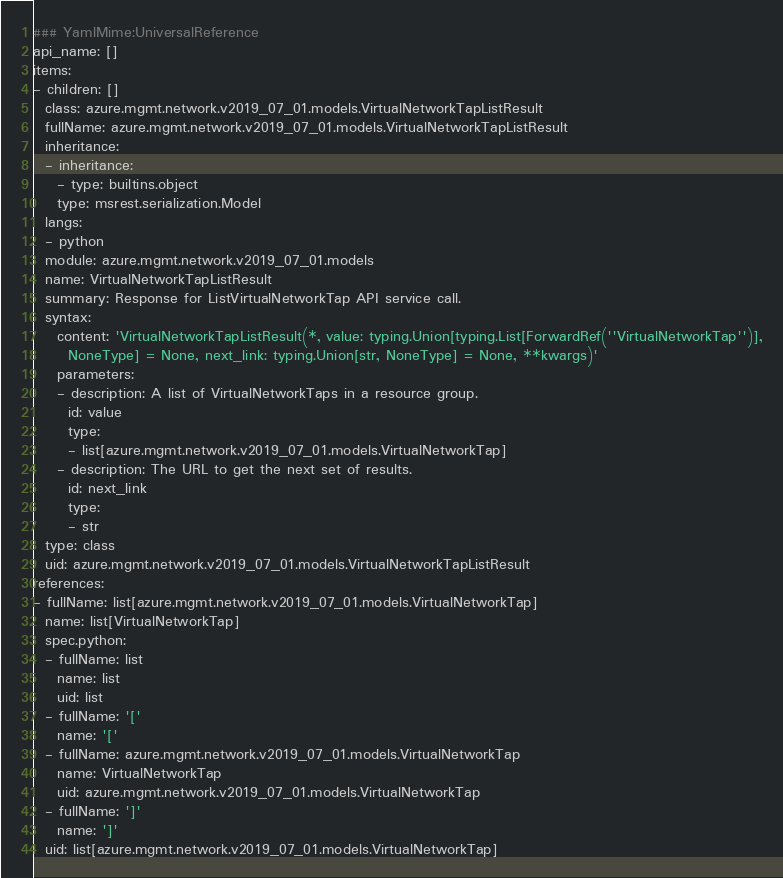Convert code to text. <code><loc_0><loc_0><loc_500><loc_500><_YAML_>### YamlMime:UniversalReference
api_name: []
items:
- children: []
  class: azure.mgmt.network.v2019_07_01.models.VirtualNetworkTapListResult
  fullName: azure.mgmt.network.v2019_07_01.models.VirtualNetworkTapListResult
  inheritance:
  - inheritance:
    - type: builtins.object
    type: msrest.serialization.Model
  langs:
  - python
  module: azure.mgmt.network.v2019_07_01.models
  name: VirtualNetworkTapListResult
  summary: Response for ListVirtualNetworkTap API service call.
  syntax:
    content: 'VirtualNetworkTapListResult(*, value: typing.Union[typing.List[ForwardRef(''VirtualNetworkTap'')],
      NoneType] = None, next_link: typing.Union[str, NoneType] = None, **kwargs)'
    parameters:
    - description: A list of VirtualNetworkTaps in a resource group.
      id: value
      type:
      - list[azure.mgmt.network.v2019_07_01.models.VirtualNetworkTap]
    - description: The URL to get the next set of results.
      id: next_link
      type:
      - str
  type: class
  uid: azure.mgmt.network.v2019_07_01.models.VirtualNetworkTapListResult
references:
- fullName: list[azure.mgmt.network.v2019_07_01.models.VirtualNetworkTap]
  name: list[VirtualNetworkTap]
  spec.python:
  - fullName: list
    name: list
    uid: list
  - fullName: '['
    name: '['
  - fullName: azure.mgmt.network.v2019_07_01.models.VirtualNetworkTap
    name: VirtualNetworkTap
    uid: azure.mgmt.network.v2019_07_01.models.VirtualNetworkTap
  - fullName: ']'
    name: ']'
  uid: list[azure.mgmt.network.v2019_07_01.models.VirtualNetworkTap]
</code> 